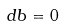<formula> <loc_0><loc_0><loc_500><loc_500>d b = 0</formula> 